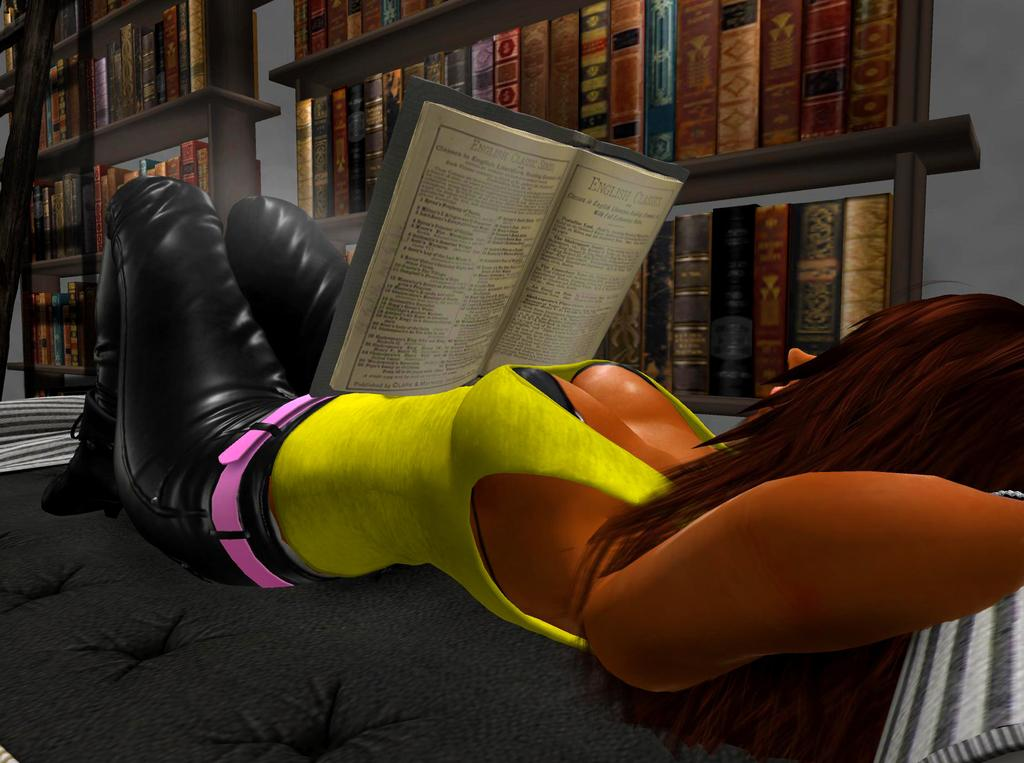What is the woman in the image doing? The animated woman is lying on the bed. What is the woman holding in her hand? The woman has a book in her hand. Is the book opened or closed? The book is opened. Where is the book rack located in the image? The book rack is beside the bed. How many books are on the book rack? The book rack is full of books. What type of rhythm is the woman dancing to in the image? There is no indication in the image that the woman is dancing, and therefore no rhythm can be determined. 